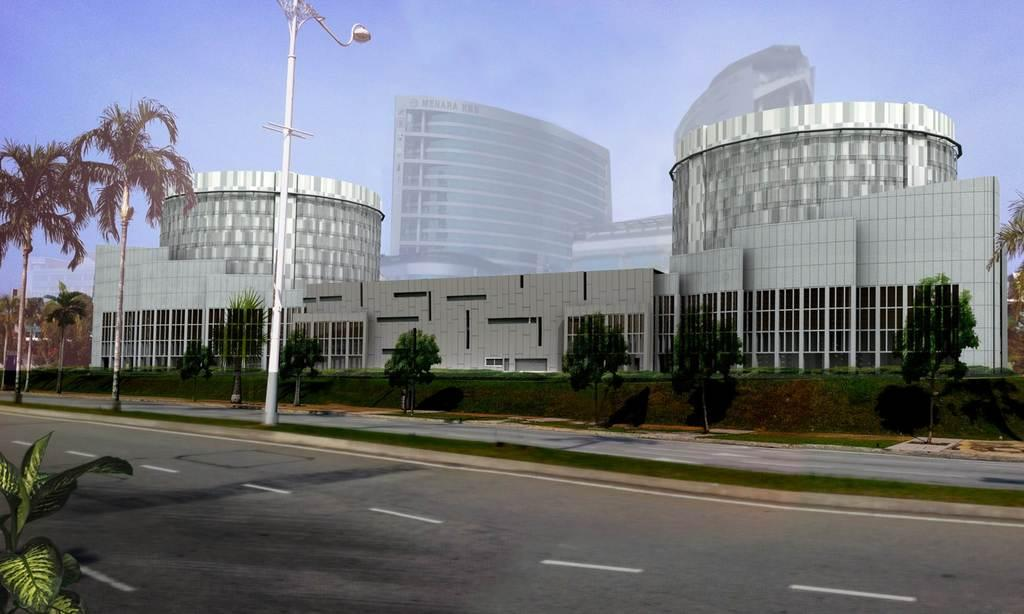What type of surface can be seen in the image? There is a road in the image. What type of vegetation is present in the image? Leaves, grass, and trees are present in the image. What type of structure is visible in the image? There is a light pole in the image. What type of man-made structures can be seen in the image? Buildings are visible in the image. What part of the natural environment is visible in the background of the image? The sky is visible in the background of the image. What type of ink can be seen spilled on the road in the image? There is no ink spilled on the road in the image. How many sheep are present in the image? There are no sheep present in the image. 